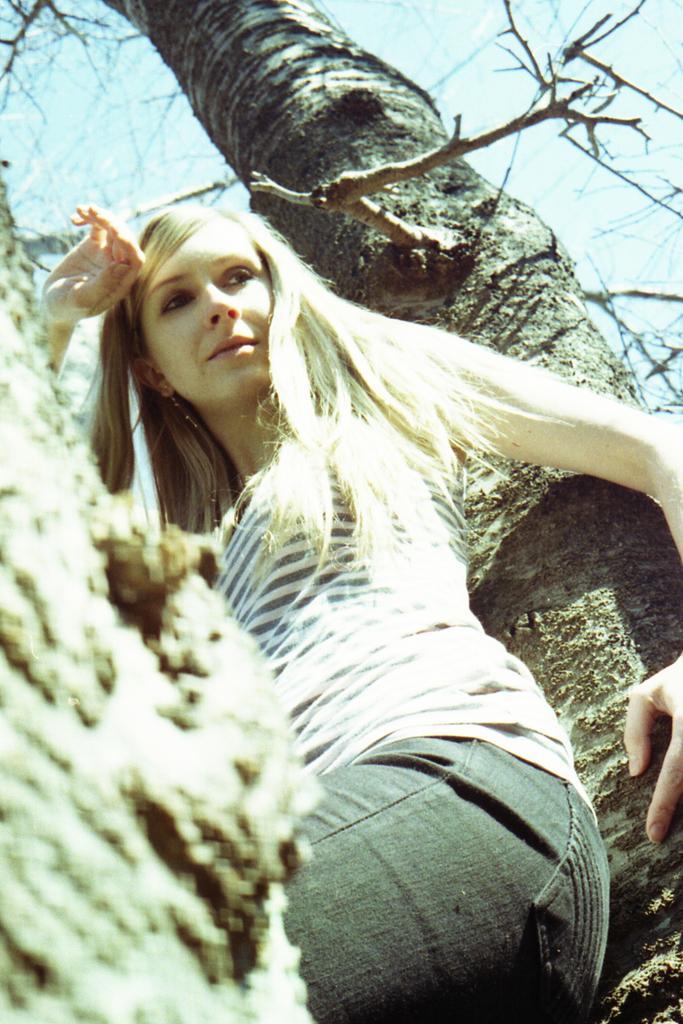Describe this image in one or two sentences. In this image in the foreground there is one person who is sitting on a tree, and in the background there is a tree. 